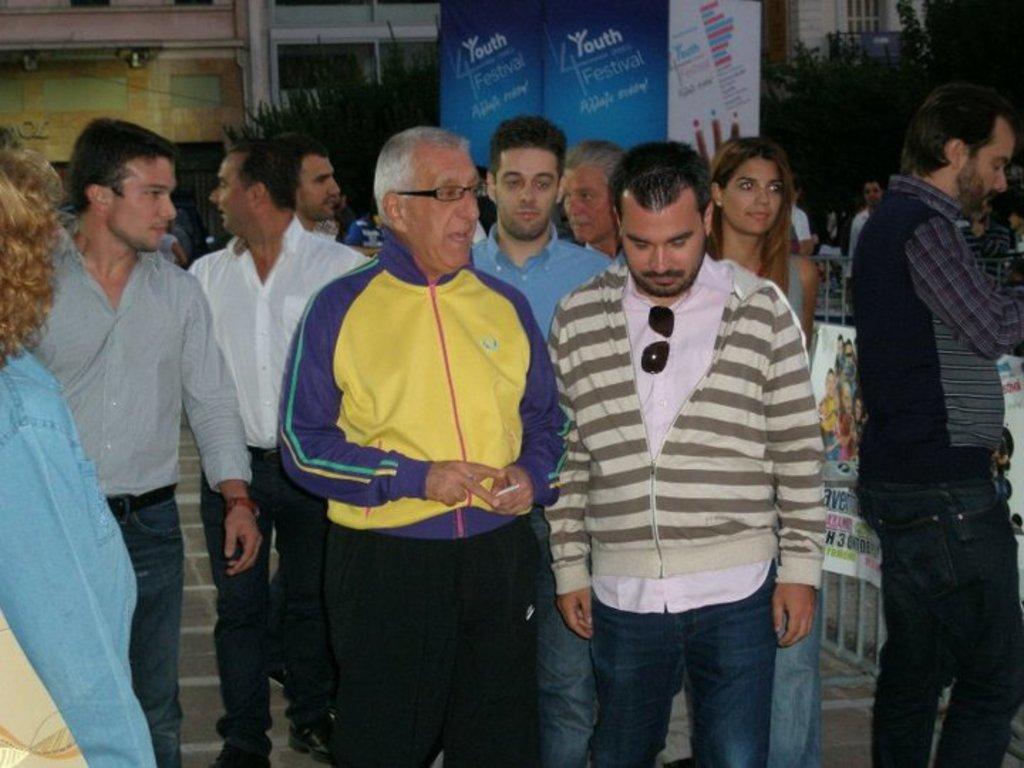Describe this image in one or two sentences. In this image there are group of persons, there is a man holding an object and talking, there are boards, there is text on the boards, there are trees, there are buildings towards the top of the image. 